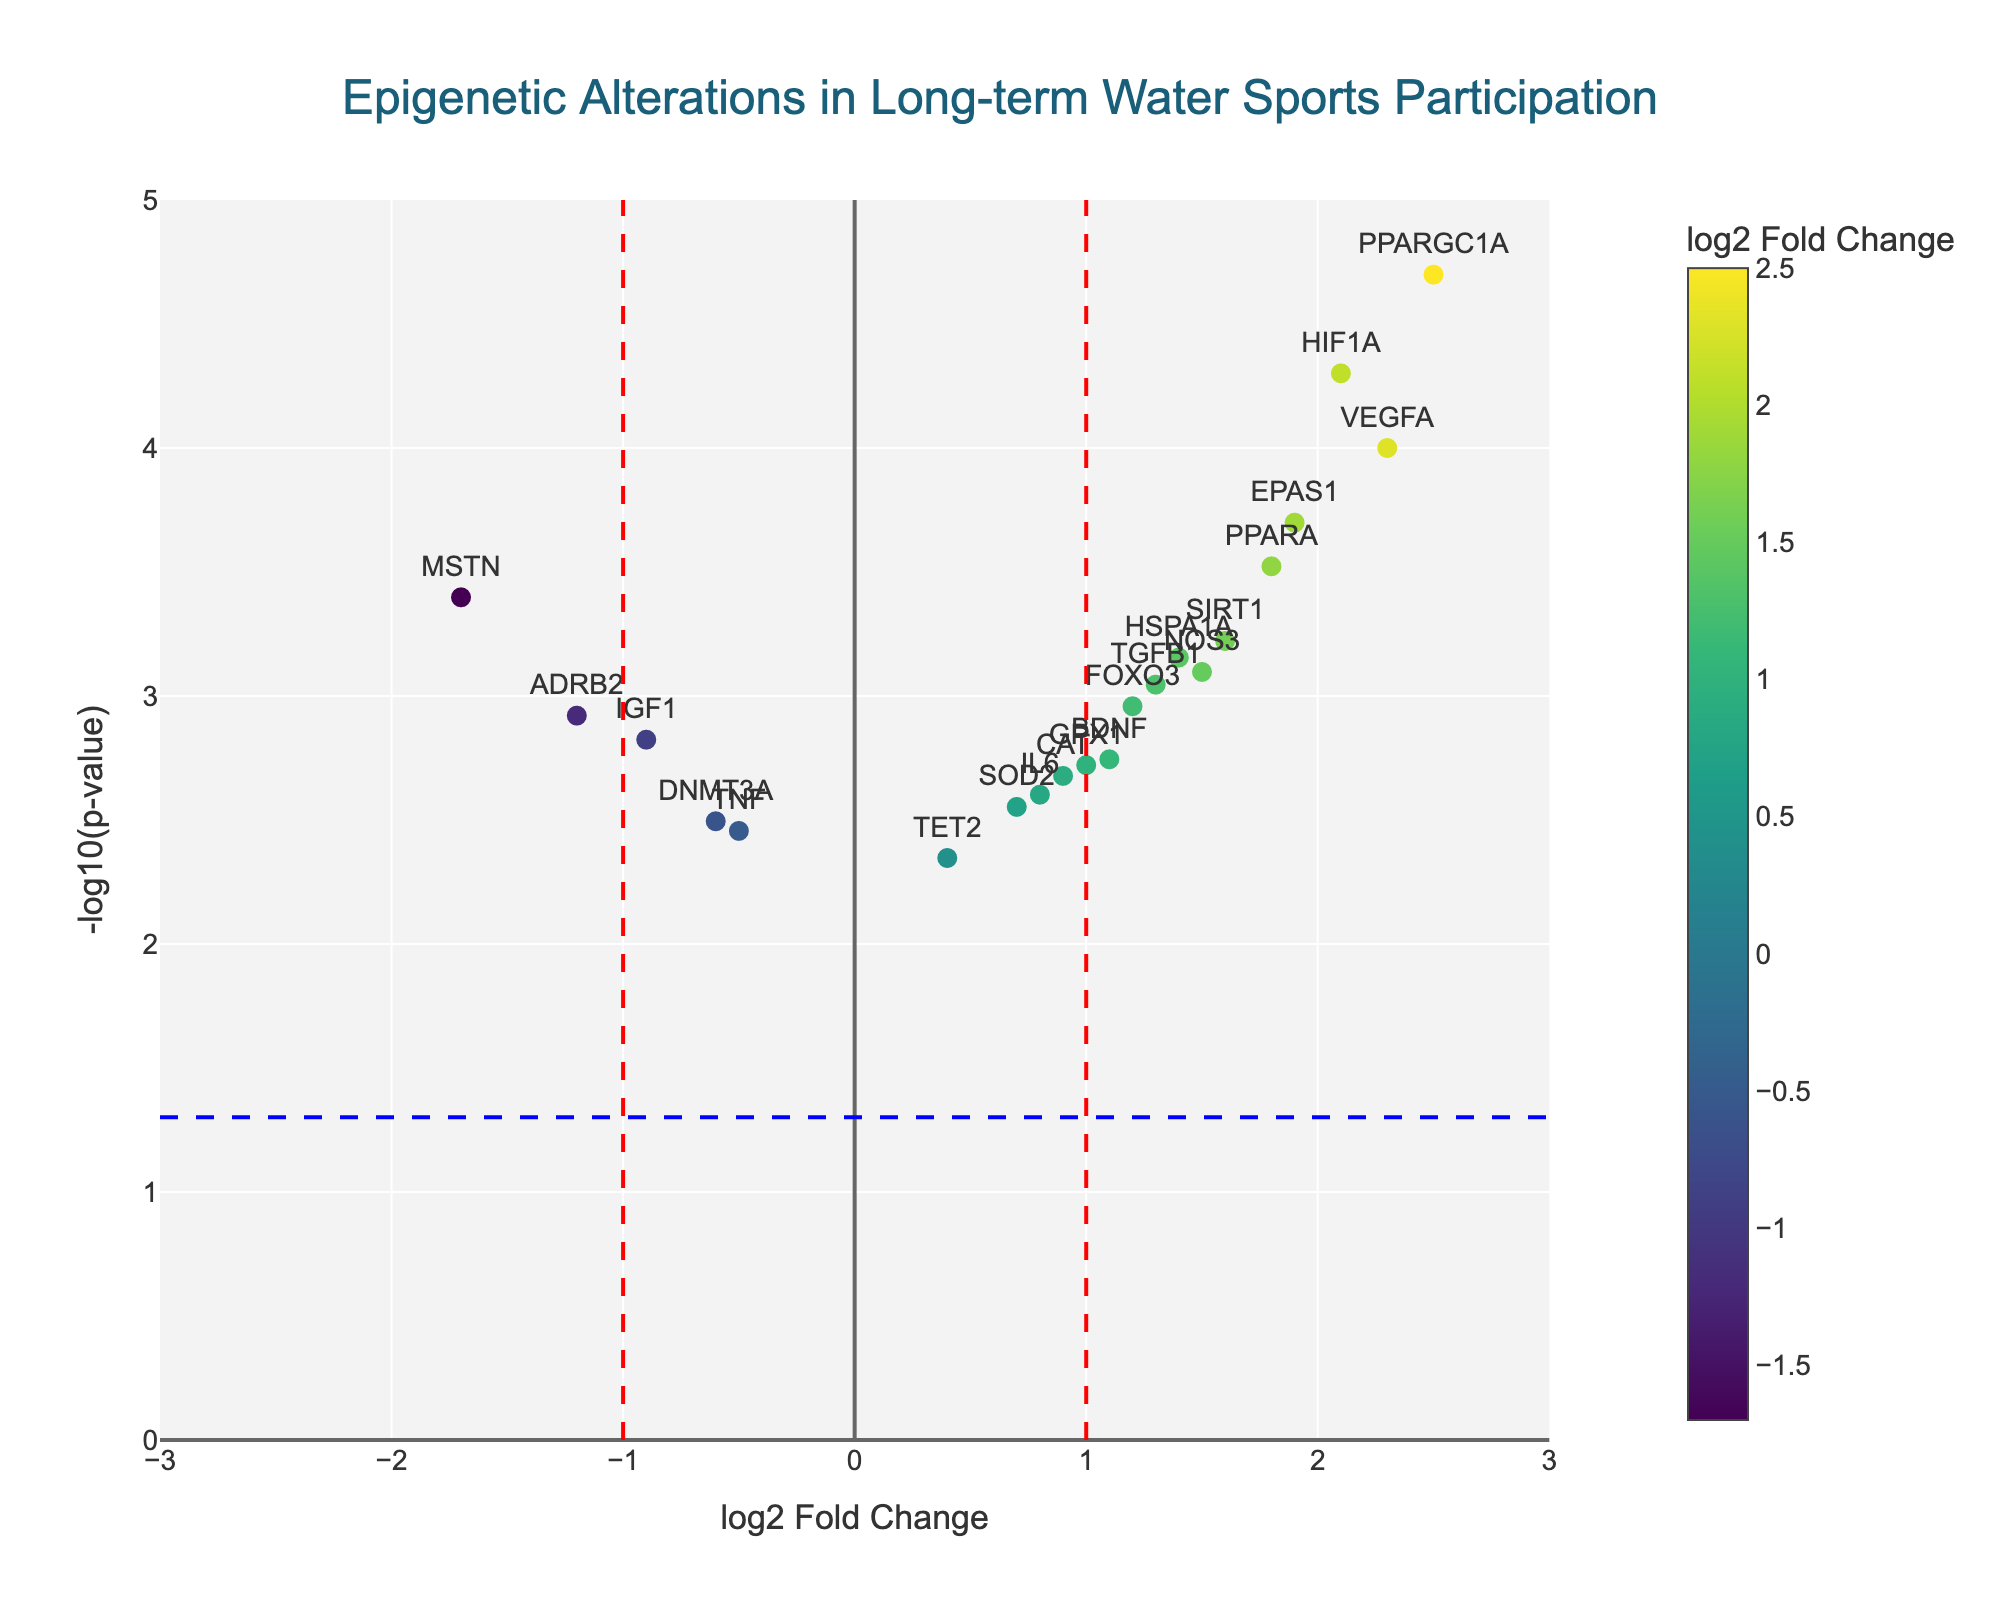What does the plot's title indicate about the data presented? The plot's title indicates that the data presented are about epigenetic alterations associated with long-term water sports participation, suggesting the genes have been studied in a group of individuals involved in water sports over an extended period.
Answer: Epigenetic alterations in long-term water sports participation How many genes show a positive log2 fold change? To determine the number of genes with a positive log2 fold change, we count the number of data points positioned to the right of the zero line on the x-axis.
Answer: 13 Which gene has the highest significance level? Significance level in the plot is indicated by the highest -log10(p-value) on the y-axis. The gene corresponding to the highest y-axis point is HIF1A.
Answer: HIF1A What color represents the highest log2 fold change in the plot? The color scale indicated in the figure shows that the highest log2 fold change is represented by the lightest color, which is close to yellow-green on a Viridis color scale.
Answer: Yellow-green What is the range of log2 fold changes shown on the x-axis? The x-axis ranges from -3 to 3, according to the x-axis limits displayed in the plot.
Answer: -3 to 3 Identify the gene with the most significant negative log2 fold change. The most significant negative log2 fold change means the highest -log10(p-value) for a negative log2 fold change value. The leftmost point in the plot with the highest y-value corresponds to MSTN.
Answer: MSTN How many genes are considered significantly altered based on the default p-value threshold (0.05)? The default p-value threshold is indicated by the horizontal blue dashed line at -log10(0.05). To determine the number of genes above this line, we count all data points positioned higher than this threshold.
Answer: 11 Which gene has the highest log2 fold change, and what is its corresponding p-value? The gene with the highest log2 fold change is located farthest to the right on the x-axis, which is PPARGC1A. We can see its corresponding p-value in the figure's hover text.
Answer: PPARGC1A, 0.00002 Are there more upregulated or downregulated genes based on their log2 fold change values? Upregulated genes have positive log2 fold change values, while downregulated genes have negative values. By counting, there are 13 upregulated genes and 7 downregulated genes, indicating more upregulation.
Answer: More upregulated genes 